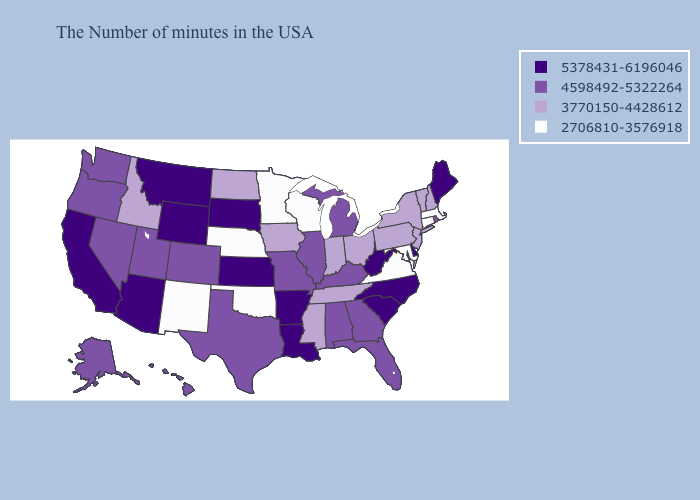How many symbols are there in the legend?
Give a very brief answer. 4. Which states have the lowest value in the South?
Concise answer only. Maryland, Virginia, Oklahoma. Does Washington have a higher value than Minnesota?
Write a very short answer. Yes. What is the lowest value in the USA?
Short answer required. 2706810-3576918. How many symbols are there in the legend?
Answer briefly. 4. Does Indiana have the same value as Idaho?
Keep it brief. Yes. Does the first symbol in the legend represent the smallest category?
Be succinct. No. What is the value of Nevada?
Give a very brief answer. 4598492-5322264. Does Florida have the highest value in the South?
Short answer required. No. Name the states that have a value in the range 4598492-5322264?
Give a very brief answer. Rhode Island, Florida, Georgia, Michigan, Kentucky, Alabama, Illinois, Missouri, Texas, Colorado, Utah, Nevada, Washington, Oregon, Alaska, Hawaii. Does Alabama have a lower value than Nevada?
Short answer required. No. What is the value of Illinois?
Be succinct. 4598492-5322264. What is the value of Ohio?
Give a very brief answer. 3770150-4428612. How many symbols are there in the legend?
Concise answer only. 4. What is the highest value in the West ?
Keep it brief. 5378431-6196046. 